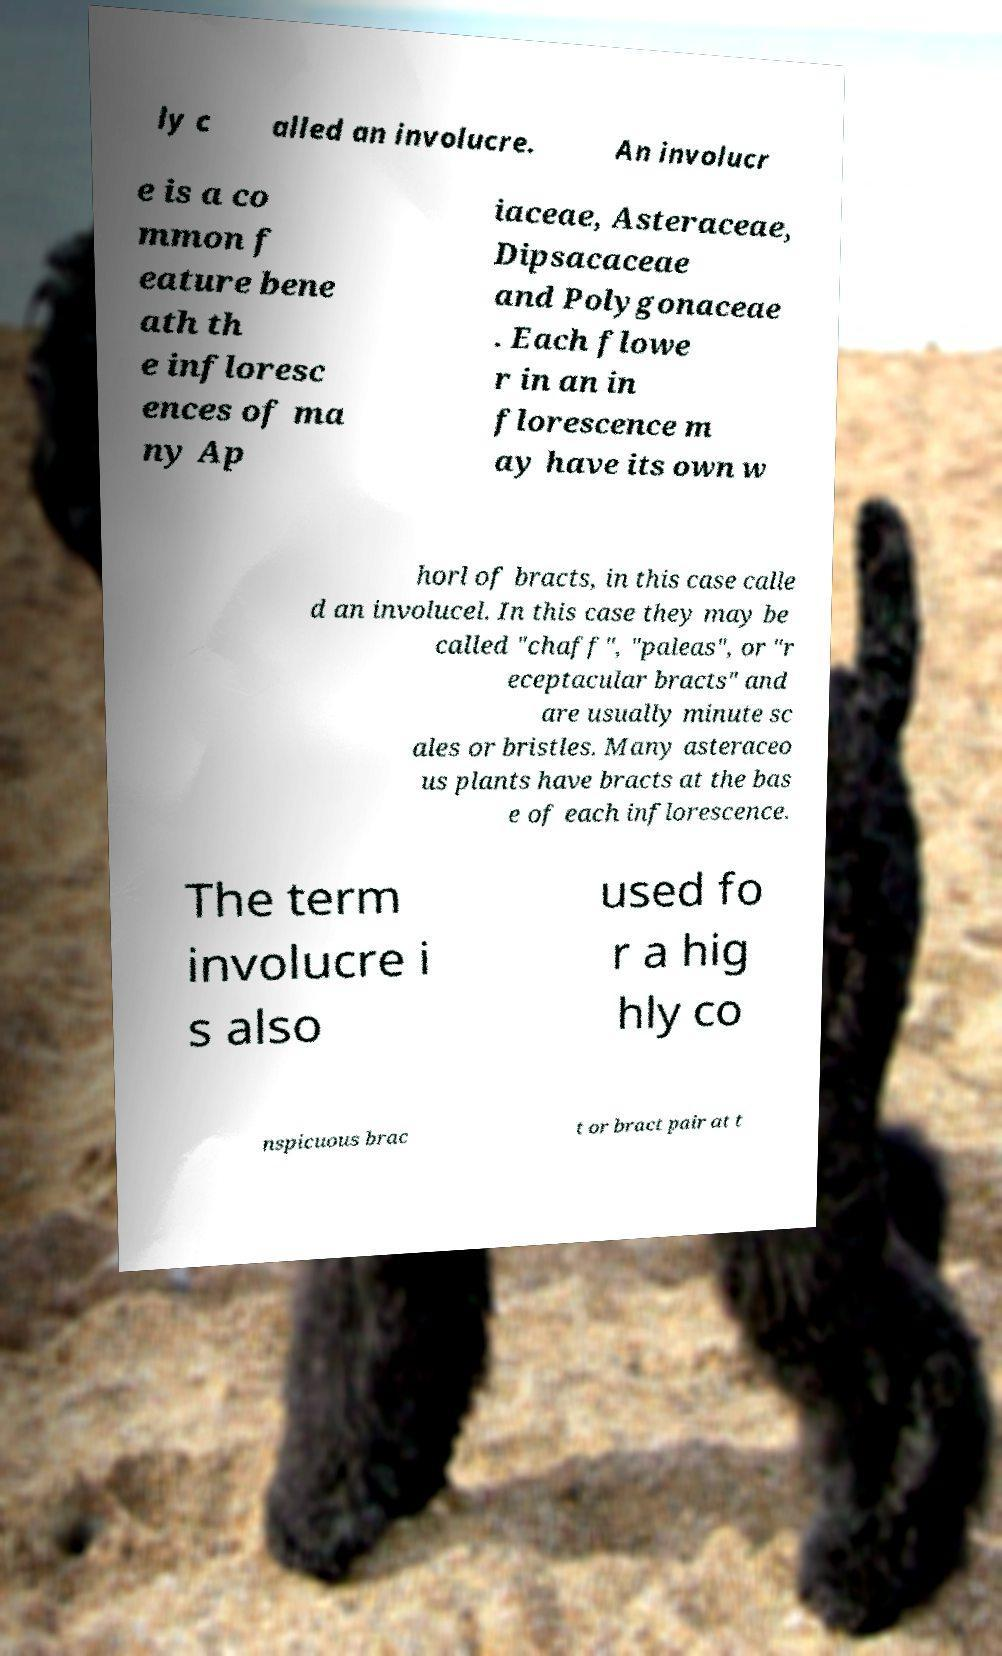Could you assist in decoding the text presented in this image and type it out clearly? ly c alled an involucre. An involucr e is a co mmon f eature bene ath th e infloresc ences of ma ny Ap iaceae, Asteraceae, Dipsacaceae and Polygonaceae . Each flowe r in an in florescence m ay have its own w horl of bracts, in this case calle d an involucel. In this case they may be called "chaff", "paleas", or "r eceptacular bracts" and are usually minute sc ales or bristles. Many asteraceo us plants have bracts at the bas e of each inflorescence. The term involucre i s also used fo r a hig hly co nspicuous brac t or bract pair at t 